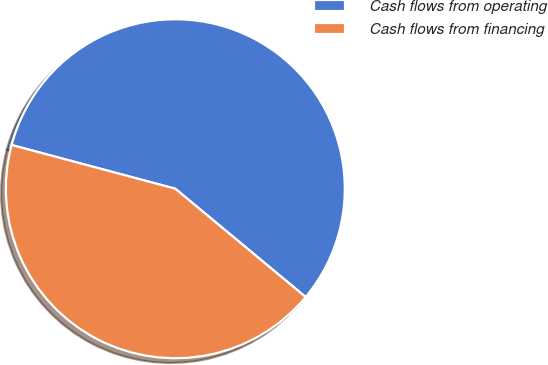Convert chart. <chart><loc_0><loc_0><loc_500><loc_500><pie_chart><fcel>Cash flows from operating<fcel>Cash flows from financing<nl><fcel>56.88%<fcel>43.12%<nl></chart> 